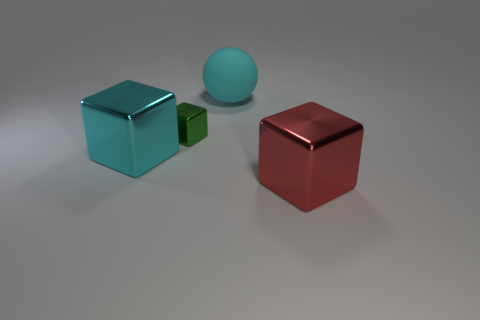Add 4 small green metallic objects. How many objects exist? 8 Subtract all blocks. How many objects are left? 1 Add 1 cyan things. How many cyan things are left? 3 Add 4 cyan rubber spheres. How many cyan rubber spheres exist? 5 Subtract 0 gray cubes. How many objects are left? 4 Subtract all tiny red spheres. Subtract all red blocks. How many objects are left? 3 